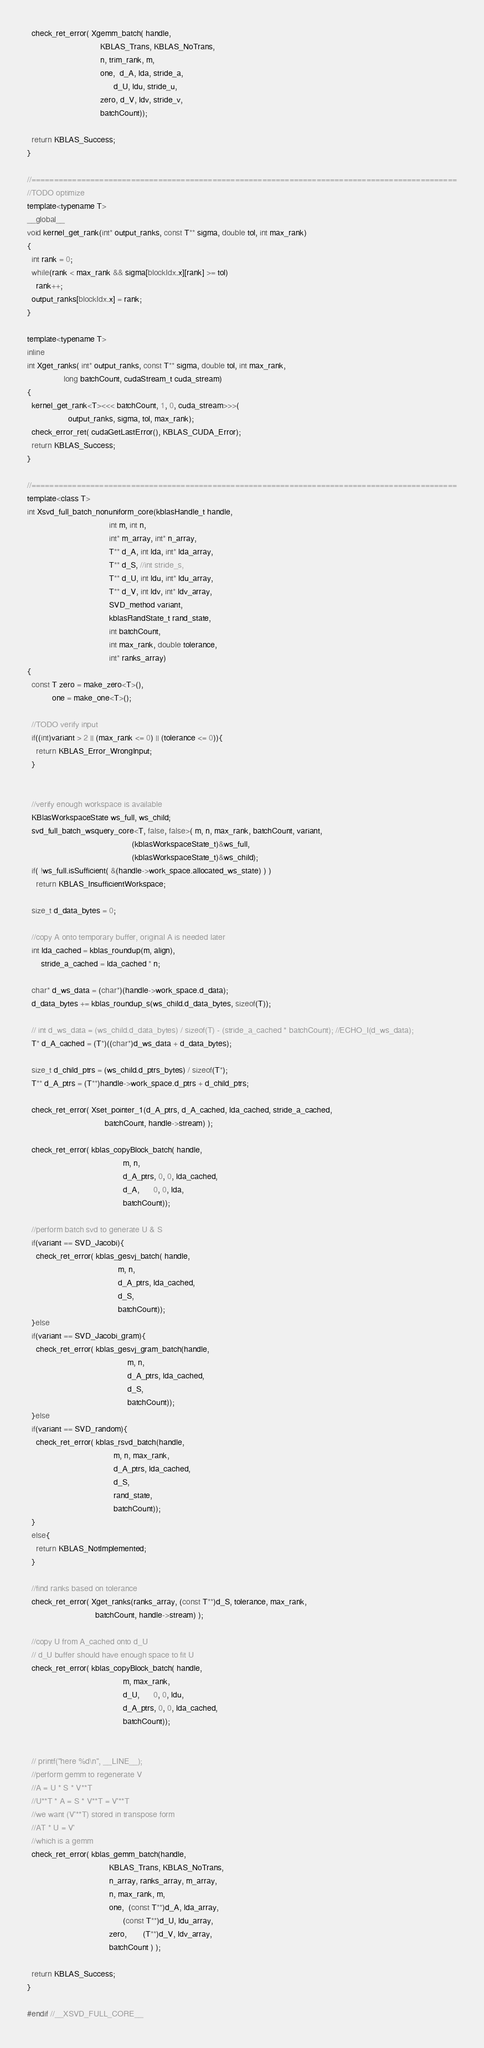Convert code to text. <code><loc_0><loc_0><loc_500><loc_500><_Cuda_>  check_ret_error( Xgemm_batch( handle,
                                KBLAS_Trans, KBLAS_NoTrans,
                                n, trim_rank, m,
                                one,  d_A, lda, stride_a,
                                      d_U, ldu, stride_u,
                                zero, d_V, ldv, stride_v,
                                batchCount));

  return KBLAS_Success;
}

//==============================================================================================
//TODO optimize
template<typename T>
__global__
void kernel_get_rank(int* output_ranks, const T** sigma, double tol, int max_rank)
{
  int rank = 0;
  while(rank < max_rank && sigma[blockIdx.x][rank] >= tol)
    rank++;
  output_ranks[blockIdx.x] = rank;
}

template<typename T>
inline
int Xget_ranks( int* output_ranks, const T** sigma, double tol, int max_rank,
                long batchCount, cudaStream_t cuda_stream)
{
  kernel_get_rank<T><<< batchCount, 1, 0, cuda_stream>>>(
                  output_ranks, sigma, tol, max_rank);
  check_error_ret( cudaGetLastError(), KBLAS_CUDA_Error);
  return KBLAS_Success;
}

//==============================================================================================
template<class T>
int Xsvd_full_batch_nonuniform_core(kblasHandle_t handle,
                                    int m, int n,
                                    int* m_array, int* n_array,
                                    T** d_A, int lda, int* lda_array,
                                    T** d_S, //int stride_s,
                                    T** d_U, int ldu, int* ldu_array,
                                    T** d_V, int ldv, int* ldv_array,
                                    SVD_method variant,
                                    kblasRandState_t rand_state,
                                    int batchCount,
                                    int max_rank, double tolerance,
                                    int* ranks_array)
{
  const T zero = make_zero<T>(),
           one = make_one<T>();

  //TODO verify input
  if((int)variant > 2 || (max_rank <= 0) || (tolerance <= 0)){
    return KBLAS_Error_WrongInput;
  }


  //verify enough workspace is available
  KBlasWorkspaceState ws_full, ws_child;
  svd_full_batch_wsquery_core<T, false, false>( m, n, max_rank, batchCount, variant,
                                              (kblasWorkspaceState_t)&ws_full,
                                              (kblasWorkspaceState_t)&ws_child);
  if( !ws_full.isSufficient( &(handle->work_space.allocated_ws_state) ) )
    return KBLAS_InsufficientWorkspace;

  size_t d_data_bytes = 0;

  //copy A onto temporary buffer, original A is needed later
  int lda_cached = kblas_roundup(m, align),
      stride_a_cached = lda_cached * n;

  char* d_ws_data = (char*)(handle->work_space.d_data);
  d_data_bytes += kblas_roundup_s(ws_child.d_data_bytes, sizeof(T));

  // int d_ws_data = (ws_child.d_data_bytes) / sizeof(T) - (stride_a_cached * batchCount); //ECHO_I(d_ws_data);
  T* d_A_cached = (T*)((char*)d_ws_data + d_data_bytes);

  size_t d_child_ptrs = (ws_child.d_ptrs_bytes) / sizeof(T*);
  T** d_A_ptrs = (T**)handle->work_space.d_ptrs + d_child_ptrs;

  check_ret_error( Xset_pointer_1(d_A_ptrs, d_A_cached, lda_cached, stride_a_cached,
                                  batchCount, handle->stream) );

  check_ret_error( kblas_copyBlock_batch( handle,
                                          m, n,
                                          d_A_ptrs, 0, 0, lda_cached,
                                          d_A,      0, 0, lda,
                                          batchCount));

  //perform batch svd to generate U & S
  if(variant == SVD_Jacobi){
    check_ret_error( kblas_gesvj_batch( handle,
                                        m, n,
                                        d_A_ptrs, lda_cached,
                                        d_S,
                                        batchCount));
  }else
  if(variant == SVD_Jacobi_gram){
    check_ret_error( kblas_gesvj_gram_batch(handle,
                                            m, n,
                                            d_A_ptrs, lda_cached,
                                            d_S,
                                            batchCount));
  }else
  if(variant == SVD_random){
    check_ret_error( kblas_rsvd_batch(handle,
                                      m, n, max_rank,
                                      d_A_ptrs, lda_cached,
                                      d_S,
                                      rand_state,
                                      batchCount));
  }
  else{
    return KBLAS_NotImplemented;
  }

  //find ranks based on tolerance
  check_ret_error( Xget_ranks(ranks_array, (const T**)d_S, tolerance, max_rank,
                              batchCount, handle->stream) );

  //copy U from A_cached onto d_U
  // d_U buffer should have enough space to fit U
  check_ret_error( kblas_copyBlock_batch( handle,
                                          m, max_rank,
                                          d_U,      0, 0, ldu,
                                          d_A_ptrs, 0, 0, lda_cached,
                                          batchCount));


  // printf("here %d\n", __LINE__);
  //perform gemm to regenerate V
  //A = U * S * V**T
  //U**T * A = S * V**T = V'**T
  //we want (V'**T) stored in transpose form
  //AT * U = V'
  //which is a gemm
  check_ret_error( kblas_gemm_batch(handle,
                                    KBLAS_Trans, KBLAS_NoTrans,
                                    n_array, ranks_array, m_array,
                                    n, max_rank, m,
                                    one,  (const T**)d_A, lda_array,
                                          (const T**)d_U, ldu_array,
                                    zero,       (T**)d_V, ldv_array,
                                    batchCount ) );

  return KBLAS_Success;
}

#endif //__XSVD_FULL_CORE__
</code> 